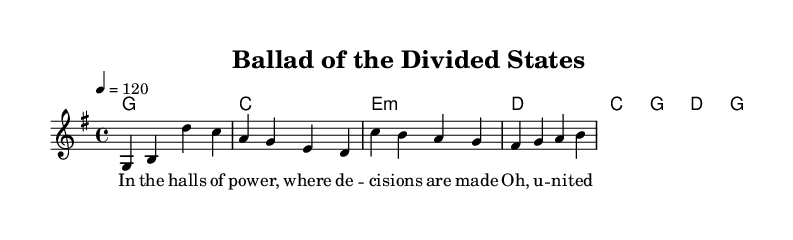What is the time signature of this music? The time signature is indicated at the beginning of the score with "4/4", meaning there are four beats in a measure.
Answer: 4/4 What is the key signature of this piece? The key signature is marked as "g major," which typically has one sharp (F#).
Answer: G major What is the tempo marking of the music? The tempo marking is specified as "4 = 120," indicating the quarter note gets a tempo of 120 beats per minute.
Answer: 120 How many measures are there in the verse section? The verse section consists of two phrases that can be counted based on the bar lines, totaling four measures.
Answer: 4 Which chords are used in the verse? The harmonies in the verse correspond to the chord symbols present above the melody and are G, C, E minor, and D, respectively.
Answer: G, C, E minor, D What lyrical theme is expressed in the song? The lyrics reflect themes of division and unity in a political context, addressing the challenges faced in governance.
Answer: Division and unity How does this song fit within the Country Rock genre? Country Rock often blends traditional country themes with rock rhythms and instrumentation, which is evident in the song's protest lyrics and musical style.
Answer: Protest themes 